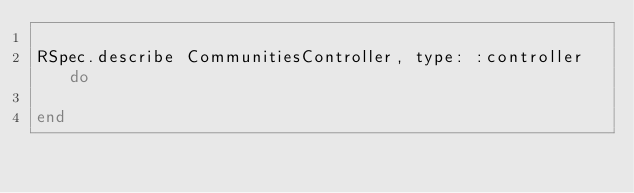<code> <loc_0><loc_0><loc_500><loc_500><_Ruby_>
RSpec.describe CommunitiesController, type: :controller do

end
</code> 